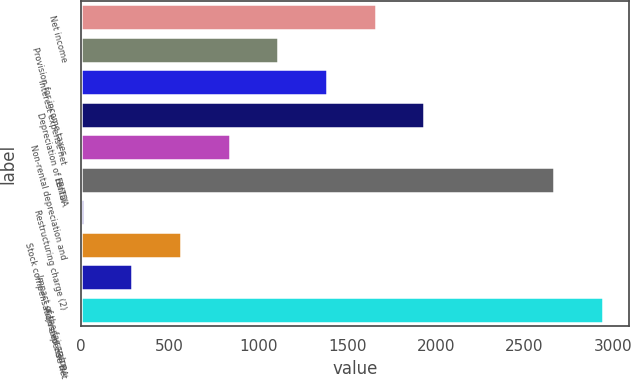Convert chart to OTSL. <chart><loc_0><loc_0><loc_500><loc_500><bar_chart><fcel>Net income<fcel>Provision for income taxes<fcel>Interest expense net<fcel>Depreciation of rental<fcel>Non-rental depreciation and<fcel>EBITDA<fcel>Restructuring charge (2)<fcel>Stock compensation expense net<fcel>Impact of the fair value<fcel>Adjusted EBITDA<nl><fcel>1661<fcel>1112<fcel>1386.5<fcel>1935.5<fcel>837.5<fcel>2665<fcel>14<fcel>563<fcel>288.5<fcel>2939.5<nl></chart> 